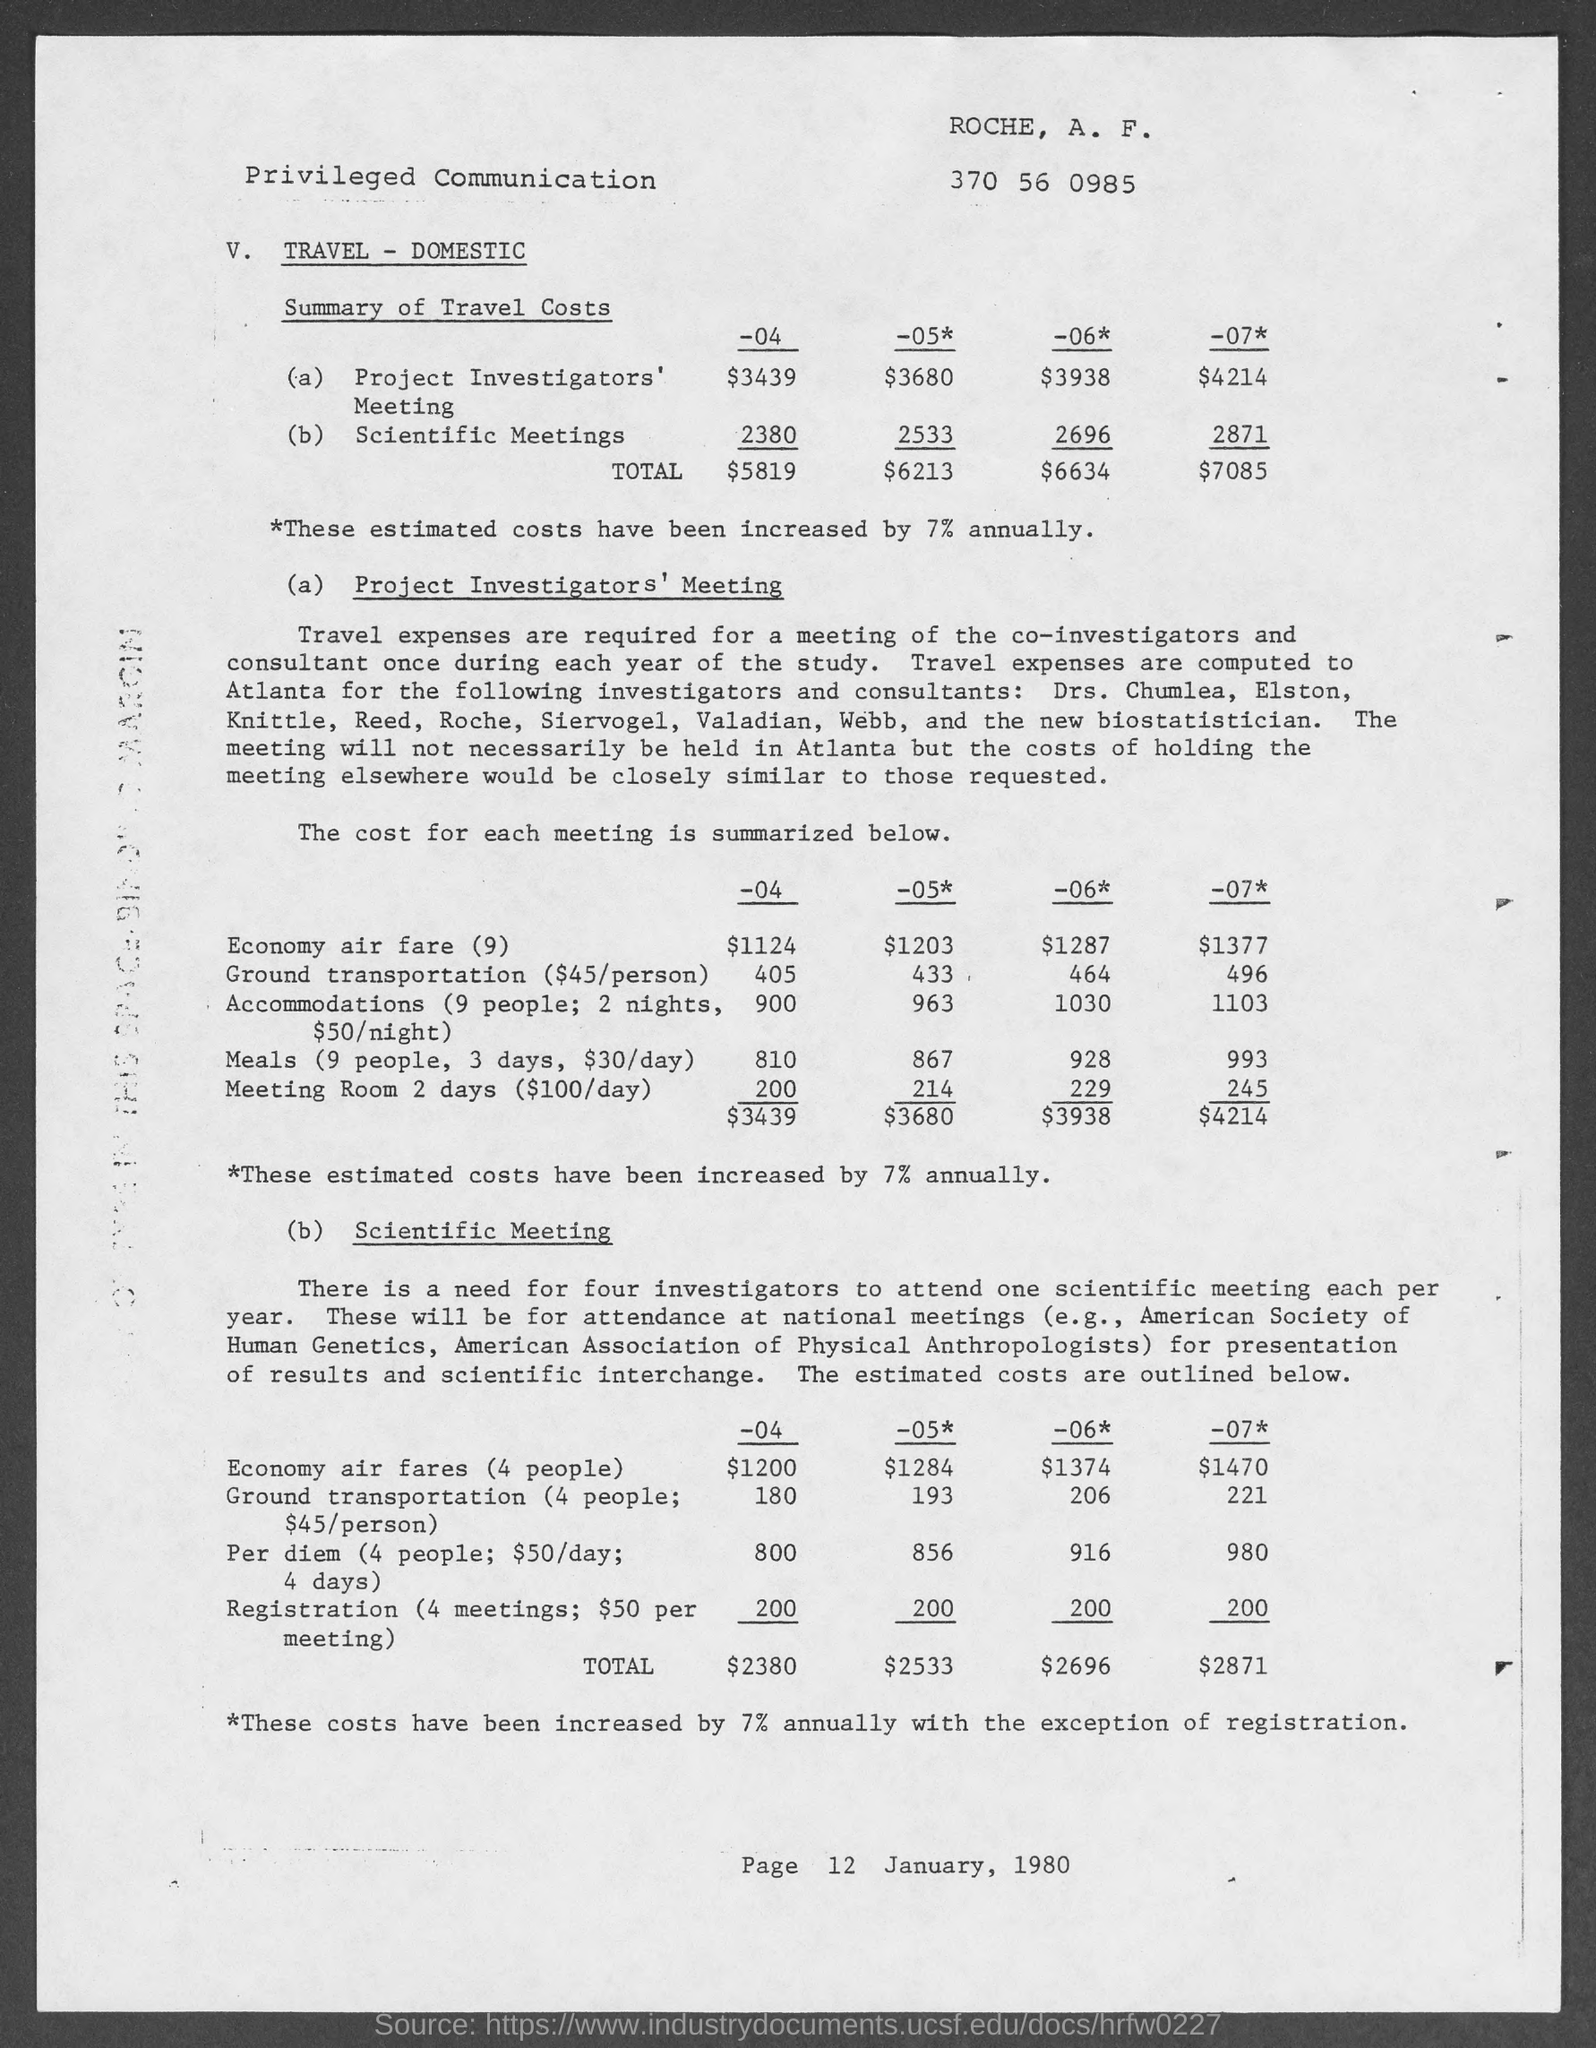Outline some significant characteristics in this image. The travel cost for the "Project Investigator's Meeting" in the year "-04" was $3439. The travel cost for scientific meetings for the year 2007 was 2,871. The total travel cost for the year 2005 is $6,213. 